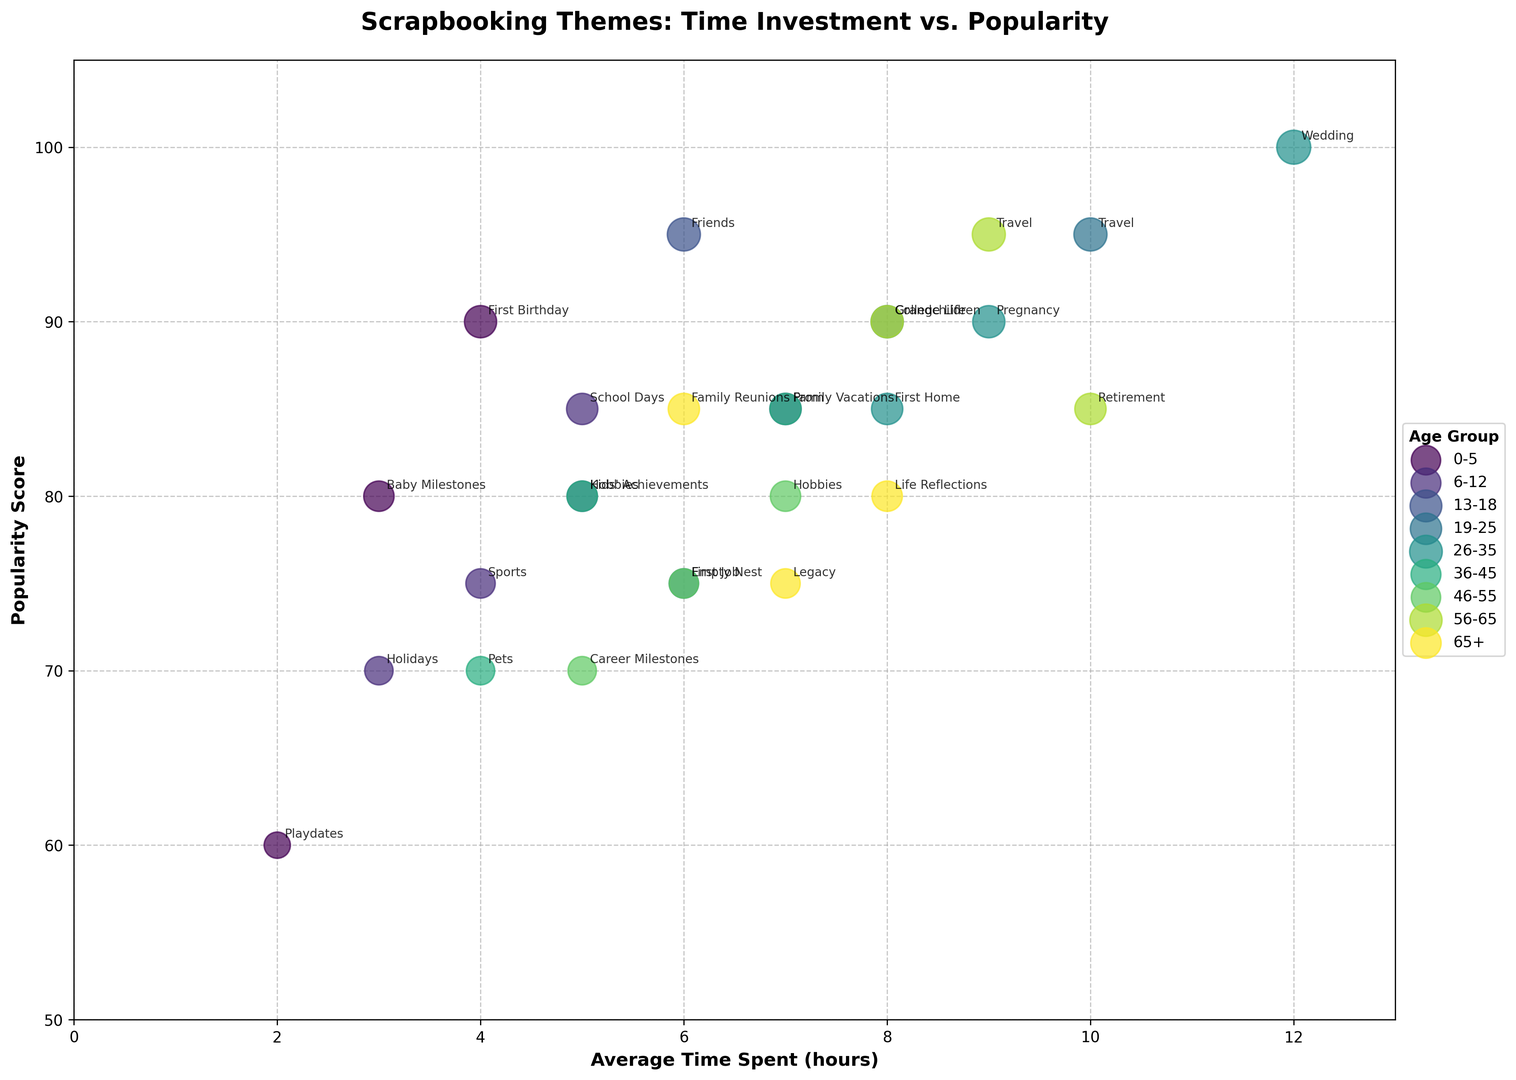What's the most popular scrapbooking theme for the 0-5 age group? The 0-5 age group includes themes like Baby Milestones, First Birthday, and Playdates. From the figure, the theme with the highest popularity score (90) in this age group is First Birthday.
Answer: First Birthday Which age group themes have an average time spent of more than 10 hours? By inspecting the bubble chart for themes with an average time spent greater than 10 hours, only the theme Wedding in the 26-35 age group has an average time spent of 12 hours.
Answer: 26-35 Between "College Life" and "Career Milestones," which theme is more popular and by how much? The popularity score for College Life (19-25 age group) is 90, and for Career Milestones (46-55 age group) it is 70. The difference in popularity scores is 90 - 70 = 20.
Answer: College Life by 20 What is the average popularity score for the 26-35 age group themes? The 26-35 age group includes Wedding (100), First Home (85), and Pregnancy (90). The average popularity score is (100 + 85 + 90) / 3 = 91.67.
Answer: 91.67 Are there any themes in the 13-18 age group that require more than 6 hours on average? In the 13-18 age group, the themes are Friends (6 hours), Hobbies (5 hours), and Prom (7 hours). Only the Prom theme requires more than 6 hours on average.
Answer: Prom Which theme corresponds to the theme with the highest average time spent across all age groups and what is the average time spent? The highest average time spent is for the 26-35 age group's Wedding theme with 12 hours.
Answer: Wedding, 12 hours Compare the popularity of the "Travel" theme in the 19-25 and 56-65 age groups. The "Travel" theme appears in both the 19-25 (Popularity Score 95) and 56-65 (Popularity Score 95) age groups. Both have the same popularity score of 95.
Answer: Equal (95) Which age group has the highest number of themes and how many? By counting the themes in each age group from the chart, the 36-45 age group has the highest number of themes with a total of 3 themes (Family Vacations, Kids' Achievements, Pets).
Answer: 36-45, 3 themes What's the combined average time spent on all scrapbooking themes in the 65+ age group? The themes in the 65+ age group are Family Reunions (6 hours), Life Reflections (8 hours), and Legacy (7 hours). The combined average time spent is 6 + 8 + 7 = 21 hours.
Answer: 21 hours Which theme has the highest popularity score, and what is the associated age group? By inspecting the chart, the theme with the highest popularity score is Wedding with a score of 100 in the 26-35 age group.
Answer: Wedding, 26-35 